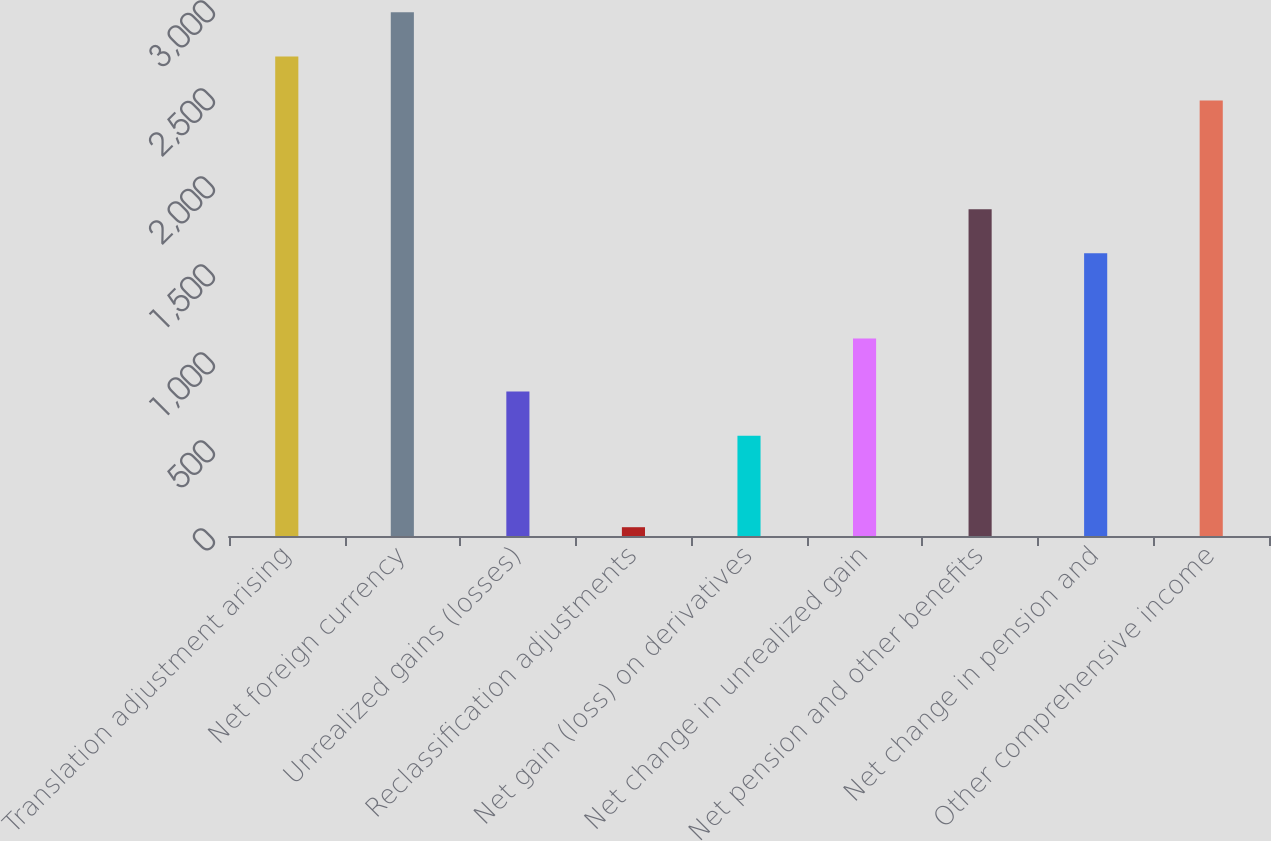<chart> <loc_0><loc_0><loc_500><loc_500><bar_chart><fcel>Translation adjustment arising<fcel>Net foreign currency<fcel>Unrealized gains (losses)<fcel>Reclassification adjustments<fcel>Net gain (loss) on derivatives<fcel>Net change in unrealized gain<fcel>Net pension and other benefits<fcel>Net change in pension and<fcel>Other comprehensive income<nl><fcel>2725<fcel>2976<fcel>821<fcel>50<fcel>570<fcel>1122<fcel>1857<fcel>1606<fcel>2474<nl></chart> 